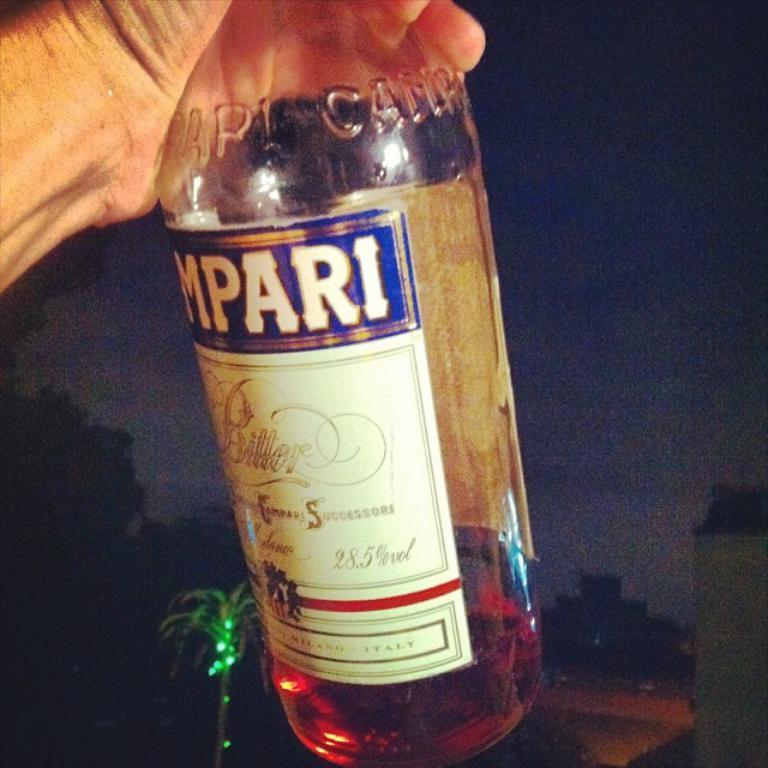Could you give a brief overview of what you see in this image? In this image I can see a glass bottle in a person hand. 